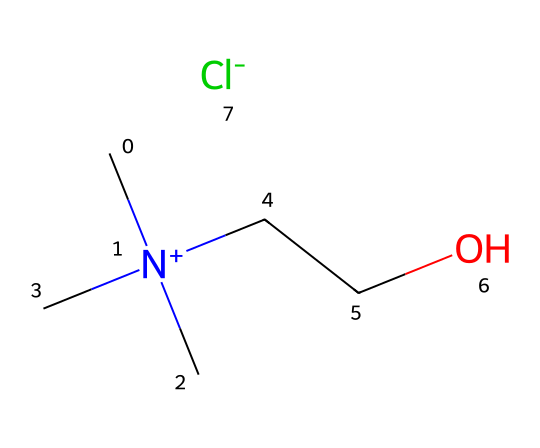What is the total number of atoms in this chemical? To find the total number of atoms, we sum the number of each type of atom present in the SMILES representation. The chemical includes: 5 Carbon atoms, 12 Hydrogen atoms, 1 Nitrogen atom, 1 Oxygen atom, and 1 Chlorine atom. Adding these together gives a total of 20 atoms.
Answer: 20 How many carbon chains are present in this ionic liquid? In the given SMILES, there are two distinct carbon chains: one stem from the trimethylammonium (C[N+](C)(C)) part with three carbons branched off the nitrogen, and another from the ethyl chain (CCO) attached to oxygen. Therefore, we count both parts, confirming that there are 2 chains.
Answer: 2 What role does the nitrogen play in this ionic liquid? The nitrogen atom is part of the ammonium group (C[N+](C)(C)) and carries a positive charge, which classifies this compound as an ionic liquid. Its charge is crucial for the ionic nature and solubility of the liquid in various solvents.
Answer: positive charge What is the significance of the chloride in this ionic liquid? The chloride anion (represented as [Cl-]) is the counterion that balances the positive charge on the nitrogen atom. This anion contributes to the ionic liquidity and stability of the formulation essential for rust removal applications.
Answer: counterion How many lone pairs are on the nitrogen in this ionic liquid structure? Nitrogen typically has one lone pair when involved in quaternary ammonium compounds. In this specific structure, the nitrogen is quaternized (has four bonds) and does not have any lone pairs: all valences are satisfied.
Answer: 0 What type of solvent characteristics can be inferred from this ionic liquid structure? The presence of a quaternary ammonium ion and a polar anion suggests that the ionic liquid will have good solvent properties, such as high polarity and the ability to dissolve both polar and nonpolar compounds, making it effective for rust removal.
Answer: high polarity 